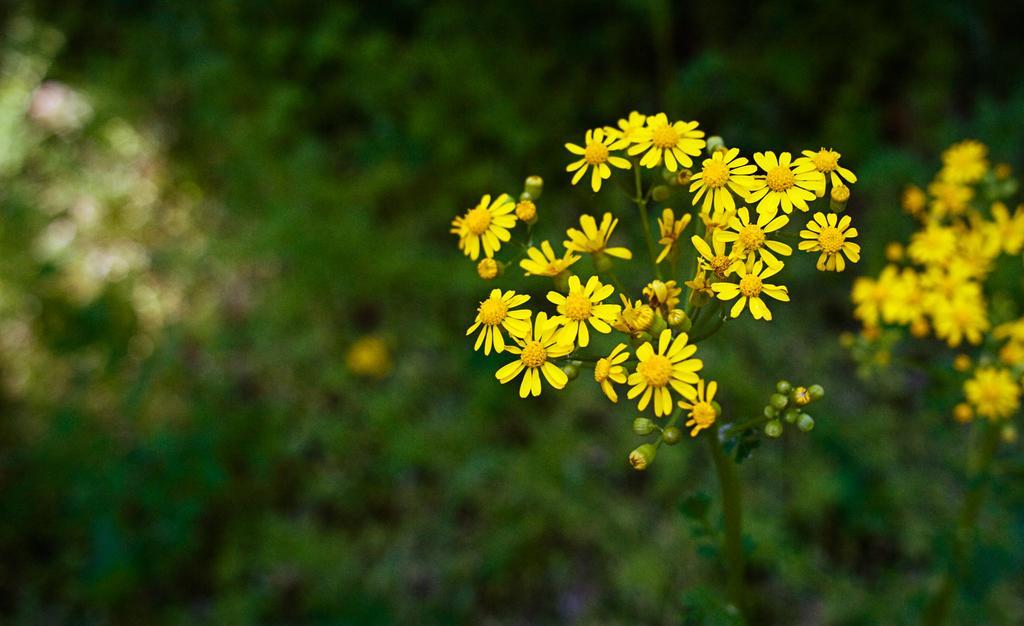Can you describe this image briefly? In this image, we can see some plants with flowers. We can also see the blurred background. 